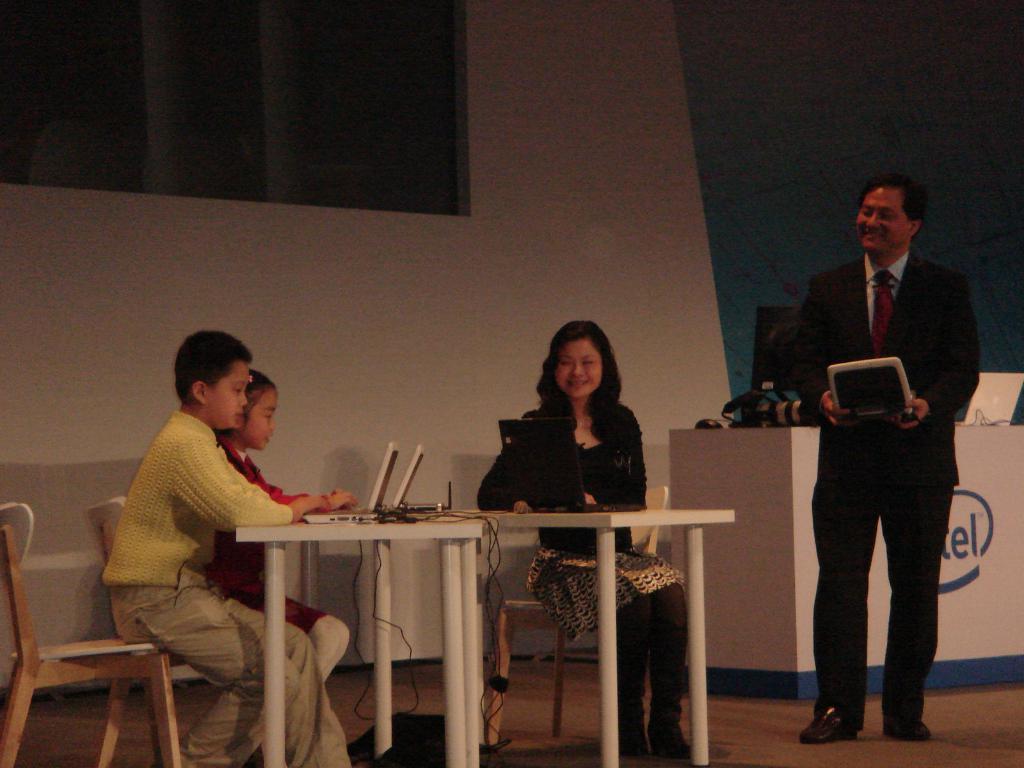Describe this image in one or two sentences. The picture taken in a room where at the right corner one person is standing and holding a system, behind him there is one table on which laptop is present and at the left corner of the picture there are three people sitting on the chairs and in front of the tables and on the table there are laptops and behind them there is a big wall. 